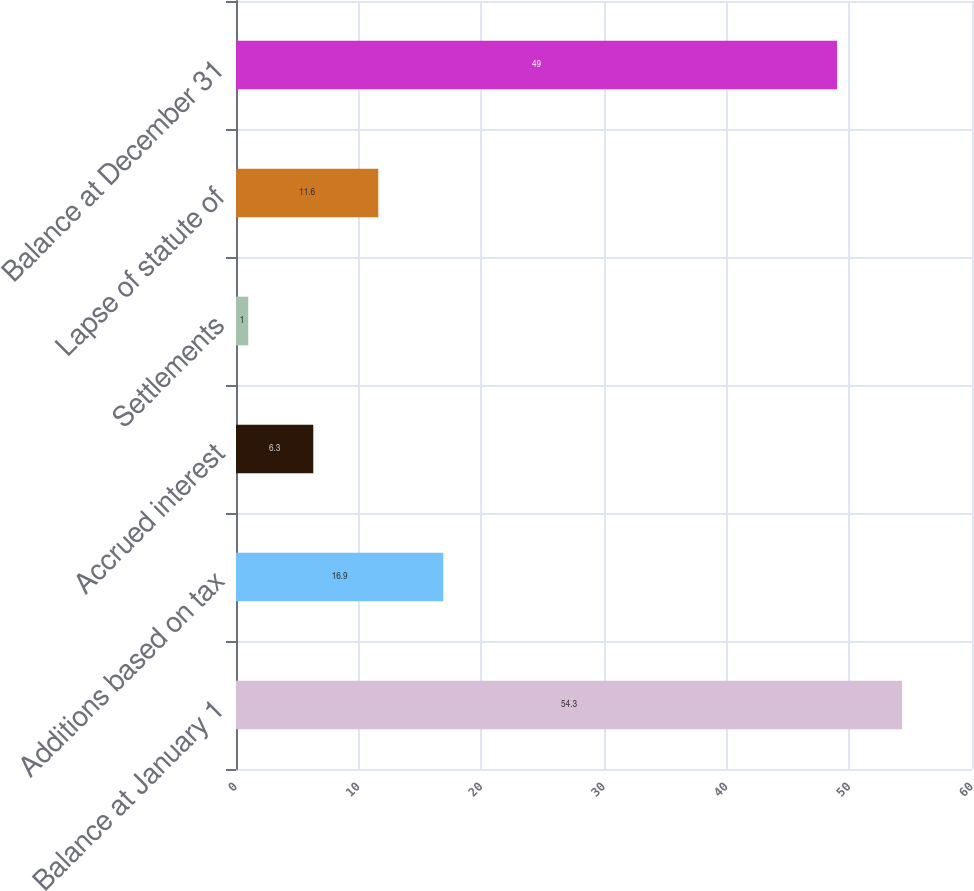Convert chart to OTSL. <chart><loc_0><loc_0><loc_500><loc_500><bar_chart><fcel>Balance at January 1<fcel>Additions based on tax<fcel>Accrued interest<fcel>Settlements<fcel>Lapse of statute of<fcel>Balance at December 31<nl><fcel>54.3<fcel>16.9<fcel>6.3<fcel>1<fcel>11.6<fcel>49<nl></chart> 